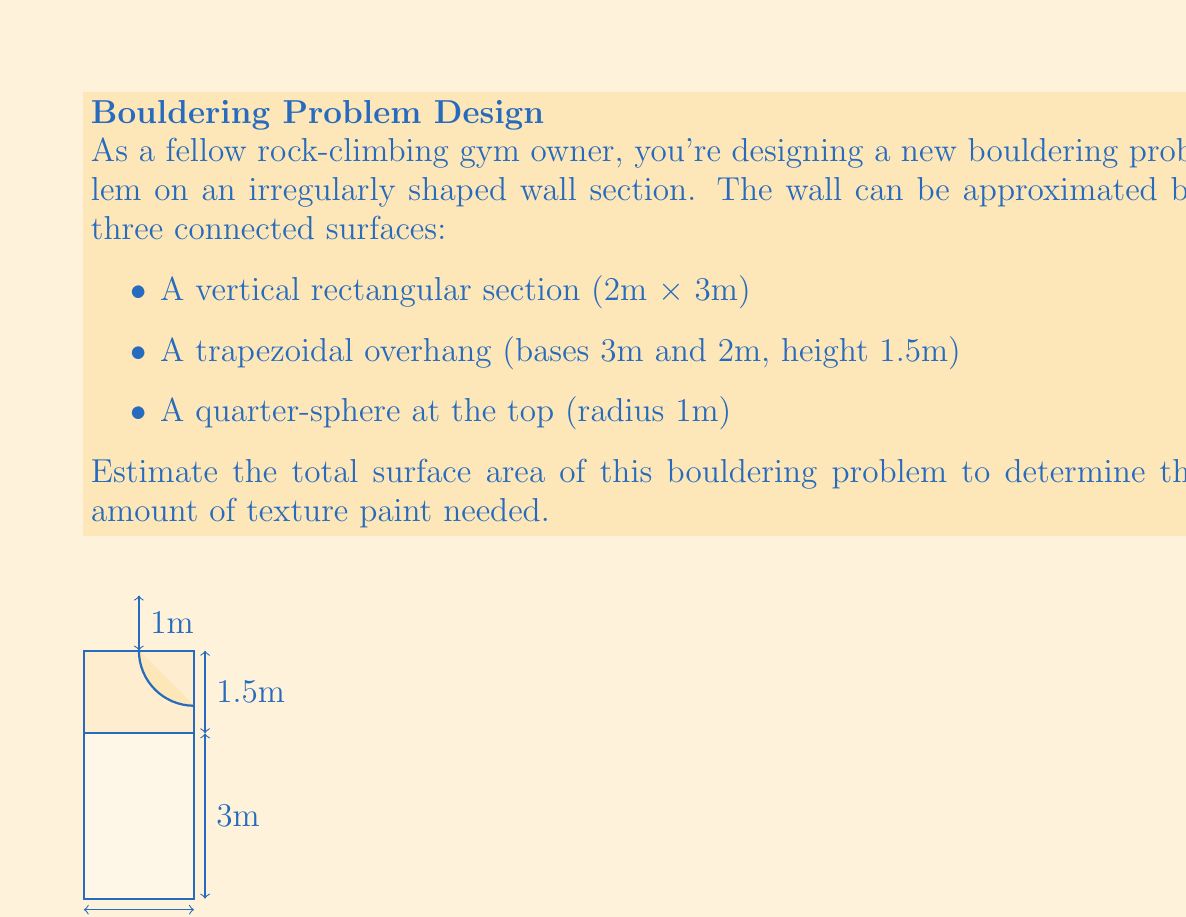Can you answer this question? Let's break this down step-by-step:

1) Rectangular section:
   Area = length × width
   $A_r = 2m \times 3m = 6m^2$

2) Trapezoidal overhang:
   Area = $\frac{1}{2}(a+b)h$, where $a$ and $b$ are parallel sides and $h$ is height
   $A_t = \frac{1}{2}(3m + 2m) \times 1.5m = 3.75m^2$

3) Quarter-sphere:
   Surface area of a sphere = $4\pi r^2$
   Surface area of a quarter-sphere = $\frac{1}{4} \times 4\pi r^2 = \pi r^2$
   $A_s = \pi \times (1m)^2 = \pi m^2$

4) Total surface area:
   $A_{total} = A_r + A_t + A_s$
   $A_{total} = 6m^2 + 3.75m^2 + \pi m^2$
   $A_{total} = 9.75m^2 + \pi m^2$
   $A_{total} \approx 12.89m^2$

Therefore, the estimated total surface area of the bouldering problem is approximately 12.89 square meters.
Answer: $12.89m^2$ 